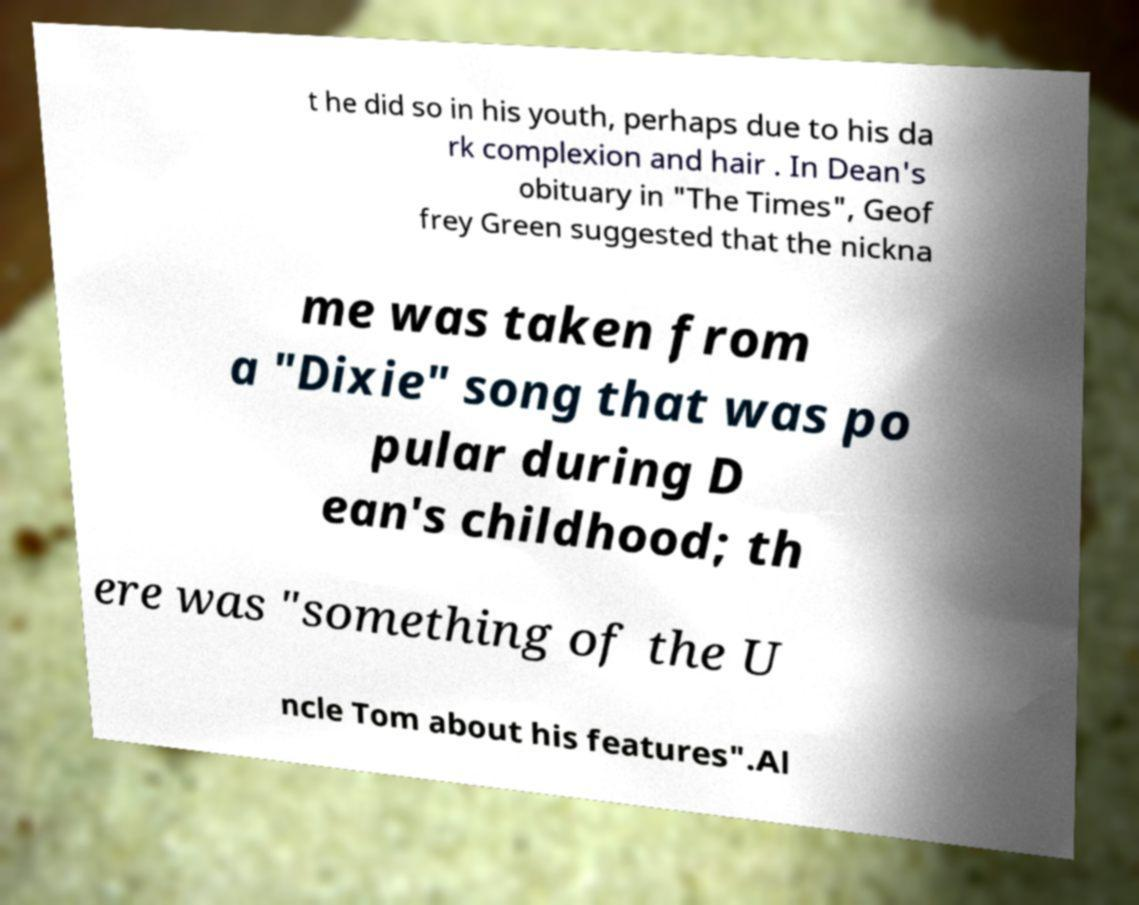Please identify and transcribe the text found in this image. t he did so in his youth, perhaps due to his da rk complexion and hair . In Dean's obituary in "The Times", Geof frey Green suggested that the nickna me was taken from a "Dixie" song that was po pular during D ean's childhood; th ere was "something of the U ncle Tom about his features".Al 